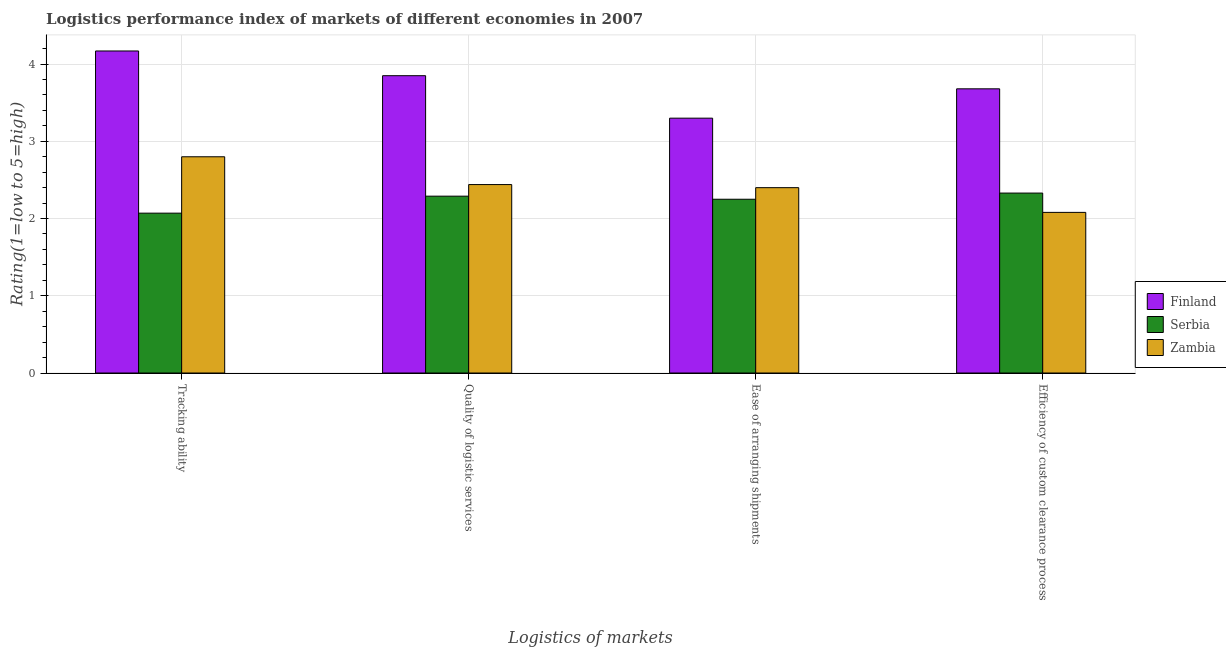Are the number of bars on each tick of the X-axis equal?
Provide a short and direct response. Yes. How many bars are there on the 1st tick from the left?
Provide a succinct answer. 3. What is the label of the 4th group of bars from the left?
Your answer should be compact. Efficiency of custom clearance process. What is the lpi rating of tracking ability in Serbia?
Your answer should be compact. 2.07. Across all countries, what is the maximum lpi rating of efficiency of custom clearance process?
Offer a very short reply. 3.68. Across all countries, what is the minimum lpi rating of tracking ability?
Your answer should be compact. 2.07. In which country was the lpi rating of tracking ability minimum?
Offer a very short reply. Serbia. What is the total lpi rating of tracking ability in the graph?
Provide a short and direct response. 9.04. What is the difference between the lpi rating of ease of arranging shipments in Serbia and that in Zambia?
Your answer should be very brief. -0.15. What is the difference between the lpi rating of ease of arranging shipments in Finland and the lpi rating of tracking ability in Serbia?
Your answer should be compact. 1.23. What is the average lpi rating of efficiency of custom clearance process per country?
Offer a very short reply. 2.7. What is the difference between the lpi rating of quality of logistic services and lpi rating of ease of arranging shipments in Zambia?
Ensure brevity in your answer.  0.04. In how many countries, is the lpi rating of ease of arranging shipments greater than 3.8 ?
Your answer should be very brief. 0. What is the ratio of the lpi rating of tracking ability in Finland to that in Serbia?
Your response must be concise. 2.01. Is the difference between the lpi rating of efficiency of custom clearance process in Zambia and Finland greater than the difference between the lpi rating of ease of arranging shipments in Zambia and Finland?
Offer a very short reply. No. What is the difference between the highest and the second highest lpi rating of tracking ability?
Give a very brief answer. 1.37. What is the difference between the highest and the lowest lpi rating of ease of arranging shipments?
Provide a succinct answer. 1.05. In how many countries, is the lpi rating of ease of arranging shipments greater than the average lpi rating of ease of arranging shipments taken over all countries?
Keep it short and to the point. 1. Is it the case that in every country, the sum of the lpi rating of tracking ability and lpi rating of quality of logistic services is greater than the sum of lpi rating of efficiency of custom clearance process and lpi rating of ease of arranging shipments?
Give a very brief answer. No. What does the 3rd bar from the left in Efficiency of custom clearance process represents?
Your answer should be very brief. Zambia. What does the 3rd bar from the right in Tracking ability represents?
Provide a short and direct response. Finland. Is it the case that in every country, the sum of the lpi rating of tracking ability and lpi rating of quality of logistic services is greater than the lpi rating of ease of arranging shipments?
Make the answer very short. Yes. How many bars are there?
Offer a very short reply. 12. Are all the bars in the graph horizontal?
Provide a succinct answer. No. How many countries are there in the graph?
Offer a terse response. 3. What is the difference between two consecutive major ticks on the Y-axis?
Offer a very short reply. 1. Does the graph contain any zero values?
Give a very brief answer. No. Does the graph contain grids?
Give a very brief answer. Yes. Where does the legend appear in the graph?
Your response must be concise. Center right. How are the legend labels stacked?
Keep it short and to the point. Vertical. What is the title of the graph?
Make the answer very short. Logistics performance index of markets of different economies in 2007. What is the label or title of the X-axis?
Your answer should be compact. Logistics of markets. What is the label or title of the Y-axis?
Offer a terse response. Rating(1=low to 5=high). What is the Rating(1=low to 5=high) of Finland in Tracking ability?
Your response must be concise. 4.17. What is the Rating(1=low to 5=high) in Serbia in Tracking ability?
Give a very brief answer. 2.07. What is the Rating(1=low to 5=high) in Finland in Quality of logistic services?
Provide a succinct answer. 3.85. What is the Rating(1=low to 5=high) in Serbia in Quality of logistic services?
Your answer should be very brief. 2.29. What is the Rating(1=low to 5=high) of Zambia in Quality of logistic services?
Your response must be concise. 2.44. What is the Rating(1=low to 5=high) of Serbia in Ease of arranging shipments?
Your answer should be compact. 2.25. What is the Rating(1=low to 5=high) in Finland in Efficiency of custom clearance process?
Your response must be concise. 3.68. What is the Rating(1=low to 5=high) of Serbia in Efficiency of custom clearance process?
Your answer should be very brief. 2.33. What is the Rating(1=low to 5=high) of Zambia in Efficiency of custom clearance process?
Your answer should be compact. 2.08. Across all Logistics of markets, what is the maximum Rating(1=low to 5=high) in Finland?
Offer a terse response. 4.17. Across all Logistics of markets, what is the maximum Rating(1=low to 5=high) of Serbia?
Give a very brief answer. 2.33. Across all Logistics of markets, what is the maximum Rating(1=low to 5=high) in Zambia?
Your response must be concise. 2.8. Across all Logistics of markets, what is the minimum Rating(1=low to 5=high) in Finland?
Make the answer very short. 3.3. Across all Logistics of markets, what is the minimum Rating(1=low to 5=high) in Serbia?
Offer a terse response. 2.07. Across all Logistics of markets, what is the minimum Rating(1=low to 5=high) in Zambia?
Provide a short and direct response. 2.08. What is the total Rating(1=low to 5=high) of Finland in the graph?
Your answer should be very brief. 15. What is the total Rating(1=low to 5=high) of Serbia in the graph?
Keep it short and to the point. 8.94. What is the total Rating(1=low to 5=high) in Zambia in the graph?
Your response must be concise. 9.72. What is the difference between the Rating(1=low to 5=high) of Finland in Tracking ability and that in Quality of logistic services?
Offer a terse response. 0.32. What is the difference between the Rating(1=low to 5=high) in Serbia in Tracking ability and that in Quality of logistic services?
Your answer should be compact. -0.22. What is the difference between the Rating(1=low to 5=high) of Zambia in Tracking ability and that in Quality of logistic services?
Your response must be concise. 0.36. What is the difference between the Rating(1=low to 5=high) in Finland in Tracking ability and that in Ease of arranging shipments?
Your answer should be very brief. 0.87. What is the difference between the Rating(1=low to 5=high) of Serbia in Tracking ability and that in Ease of arranging shipments?
Give a very brief answer. -0.18. What is the difference between the Rating(1=low to 5=high) in Finland in Tracking ability and that in Efficiency of custom clearance process?
Provide a succinct answer. 0.49. What is the difference between the Rating(1=low to 5=high) of Serbia in Tracking ability and that in Efficiency of custom clearance process?
Provide a succinct answer. -0.26. What is the difference between the Rating(1=low to 5=high) of Zambia in Tracking ability and that in Efficiency of custom clearance process?
Your answer should be very brief. 0.72. What is the difference between the Rating(1=low to 5=high) in Finland in Quality of logistic services and that in Ease of arranging shipments?
Keep it short and to the point. 0.55. What is the difference between the Rating(1=low to 5=high) of Zambia in Quality of logistic services and that in Ease of arranging shipments?
Your answer should be compact. 0.04. What is the difference between the Rating(1=low to 5=high) in Finland in Quality of logistic services and that in Efficiency of custom clearance process?
Your answer should be very brief. 0.17. What is the difference between the Rating(1=low to 5=high) in Serbia in Quality of logistic services and that in Efficiency of custom clearance process?
Your response must be concise. -0.04. What is the difference between the Rating(1=low to 5=high) in Zambia in Quality of logistic services and that in Efficiency of custom clearance process?
Provide a short and direct response. 0.36. What is the difference between the Rating(1=low to 5=high) of Finland in Ease of arranging shipments and that in Efficiency of custom clearance process?
Your answer should be very brief. -0.38. What is the difference between the Rating(1=low to 5=high) in Serbia in Ease of arranging shipments and that in Efficiency of custom clearance process?
Your response must be concise. -0.08. What is the difference between the Rating(1=low to 5=high) in Zambia in Ease of arranging shipments and that in Efficiency of custom clearance process?
Ensure brevity in your answer.  0.32. What is the difference between the Rating(1=low to 5=high) of Finland in Tracking ability and the Rating(1=low to 5=high) of Serbia in Quality of logistic services?
Give a very brief answer. 1.88. What is the difference between the Rating(1=low to 5=high) of Finland in Tracking ability and the Rating(1=low to 5=high) of Zambia in Quality of logistic services?
Your response must be concise. 1.73. What is the difference between the Rating(1=low to 5=high) of Serbia in Tracking ability and the Rating(1=low to 5=high) of Zambia in Quality of logistic services?
Keep it short and to the point. -0.37. What is the difference between the Rating(1=low to 5=high) in Finland in Tracking ability and the Rating(1=low to 5=high) in Serbia in Ease of arranging shipments?
Keep it short and to the point. 1.92. What is the difference between the Rating(1=low to 5=high) in Finland in Tracking ability and the Rating(1=low to 5=high) in Zambia in Ease of arranging shipments?
Offer a terse response. 1.77. What is the difference between the Rating(1=low to 5=high) in Serbia in Tracking ability and the Rating(1=low to 5=high) in Zambia in Ease of arranging shipments?
Make the answer very short. -0.33. What is the difference between the Rating(1=low to 5=high) of Finland in Tracking ability and the Rating(1=low to 5=high) of Serbia in Efficiency of custom clearance process?
Make the answer very short. 1.84. What is the difference between the Rating(1=low to 5=high) in Finland in Tracking ability and the Rating(1=low to 5=high) in Zambia in Efficiency of custom clearance process?
Your answer should be very brief. 2.09. What is the difference between the Rating(1=low to 5=high) of Serbia in Tracking ability and the Rating(1=low to 5=high) of Zambia in Efficiency of custom clearance process?
Make the answer very short. -0.01. What is the difference between the Rating(1=low to 5=high) in Finland in Quality of logistic services and the Rating(1=low to 5=high) in Serbia in Ease of arranging shipments?
Offer a very short reply. 1.6. What is the difference between the Rating(1=low to 5=high) of Finland in Quality of logistic services and the Rating(1=low to 5=high) of Zambia in Ease of arranging shipments?
Keep it short and to the point. 1.45. What is the difference between the Rating(1=low to 5=high) in Serbia in Quality of logistic services and the Rating(1=low to 5=high) in Zambia in Ease of arranging shipments?
Provide a succinct answer. -0.11. What is the difference between the Rating(1=low to 5=high) in Finland in Quality of logistic services and the Rating(1=low to 5=high) in Serbia in Efficiency of custom clearance process?
Ensure brevity in your answer.  1.52. What is the difference between the Rating(1=low to 5=high) of Finland in Quality of logistic services and the Rating(1=low to 5=high) of Zambia in Efficiency of custom clearance process?
Offer a very short reply. 1.77. What is the difference between the Rating(1=low to 5=high) of Serbia in Quality of logistic services and the Rating(1=low to 5=high) of Zambia in Efficiency of custom clearance process?
Provide a succinct answer. 0.21. What is the difference between the Rating(1=low to 5=high) of Finland in Ease of arranging shipments and the Rating(1=low to 5=high) of Serbia in Efficiency of custom clearance process?
Keep it short and to the point. 0.97. What is the difference between the Rating(1=low to 5=high) of Finland in Ease of arranging shipments and the Rating(1=low to 5=high) of Zambia in Efficiency of custom clearance process?
Ensure brevity in your answer.  1.22. What is the difference between the Rating(1=low to 5=high) in Serbia in Ease of arranging shipments and the Rating(1=low to 5=high) in Zambia in Efficiency of custom clearance process?
Make the answer very short. 0.17. What is the average Rating(1=low to 5=high) of Finland per Logistics of markets?
Offer a very short reply. 3.75. What is the average Rating(1=low to 5=high) of Serbia per Logistics of markets?
Ensure brevity in your answer.  2.23. What is the average Rating(1=low to 5=high) of Zambia per Logistics of markets?
Make the answer very short. 2.43. What is the difference between the Rating(1=low to 5=high) in Finland and Rating(1=low to 5=high) in Zambia in Tracking ability?
Provide a succinct answer. 1.37. What is the difference between the Rating(1=low to 5=high) of Serbia and Rating(1=low to 5=high) of Zambia in Tracking ability?
Your answer should be compact. -0.73. What is the difference between the Rating(1=low to 5=high) in Finland and Rating(1=low to 5=high) in Serbia in Quality of logistic services?
Provide a succinct answer. 1.56. What is the difference between the Rating(1=low to 5=high) of Finland and Rating(1=low to 5=high) of Zambia in Quality of logistic services?
Keep it short and to the point. 1.41. What is the difference between the Rating(1=low to 5=high) in Serbia and Rating(1=low to 5=high) in Zambia in Quality of logistic services?
Make the answer very short. -0.15. What is the difference between the Rating(1=low to 5=high) in Finland and Rating(1=low to 5=high) in Serbia in Ease of arranging shipments?
Your answer should be very brief. 1.05. What is the difference between the Rating(1=low to 5=high) in Finland and Rating(1=low to 5=high) in Zambia in Ease of arranging shipments?
Your answer should be very brief. 0.9. What is the difference between the Rating(1=low to 5=high) of Finland and Rating(1=low to 5=high) of Serbia in Efficiency of custom clearance process?
Make the answer very short. 1.35. What is the difference between the Rating(1=low to 5=high) of Finland and Rating(1=low to 5=high) of Zambia in Efficiency of custom clearance process?
Ensure brevity in your answer.  1.6. What is the ratio of the Rating(1=low to 5=high) of Finland in Tracking ability to that in Quality of logistic services?
Make the answer very short. 1.08. What is the ratio of the Rating(1=low to 5=high) of Serbia in Tracking ability to that in Quality of logistic services?
Make the answer very short. 0.9. What is the ratio of the Rating(1=low to 5=high) in Zambia in Tracking ability to that in Quality of logistic services?
Keep it short and to the point. 1.15. What is the ratio of the Rating(1=low to 5=high) of Finland in Tracking ability to that in Ease of arranging shipments?
Your response must be concise. 1.26. What is the ratio of the Rating(1=low to 5=high) in Zambia in Tracking ability to that in Ease of arranging shipments?
Ensure brevity in your answer.  1.17. What is the ratio of the Rating(1=low to 5=high) in Finland in Tracking ability to that in Efficiency of custom clearance process?
Offer a very short reply. 1.13. What is the ratio of the Rating(1=low to 5=high) of Serbia in Tracking ability to that in Efficiency of custom clearance process?
Ensure brevity in your answer.  0.89. What is the ratio of the Rating(1=low to 5=high) of Zambia in Tracking ability to that in Efficiency of custom clearance process?
Give a very brief answer. 1.35. What is the ratio of the Rating(1=low to 5=high) of Finland in Quality of logistic services to that in Ease of arranging shipments?
Your answer should be compact. 1.17. What is the ratio of the Rating(1=low to 5=high) in Serbia in Quality of logistic services to that in Ease of arranging shipments?
Keep it short and to the point. 1.02. What is the ratio of the Rating(1=low to 5=high) in Zambia in Quality of logistic services to that in Ease of arranging shipments?
Provide a short and direct response. 1.02. What is the ratio of the Rating(1=low to 5=high) of Finland in Quality of logistic services to that in Efficiency of custom clearance process?
Offer a very short reply. 1.05. What is the ratio of the Rating(1=low to 5=high) of Serbia in Quality of logistic services to that in Efficiency of custom clearance process?
Keep it short and to the point. 0.98. What is the ratio of the Rating(1=low to 5=high) in Zambia in Quality of logistic services to that in Efficiency of custom clearance process?
Keep it short and to the point. 1.17. What is the ratio of the Rating(1=low to 5=high) in Finland in Ease of arranging shipments to that in Efficiency of custom clearance process?
Give a very brief answer. 0.9. What is the ratio of the Rating(1=low to 5=high) in Serbia in Ease of arranging shipments to that in Efficiency of custom clearance process?
Your answer should be very brief. 0.97. What is the ratio of the Rating(1=low to 5=high) of Zambia in Ease of arranging shipments to that in Efficiency of custom clearance process?
Provide a short and direct response. 1.15. What is the difference between the highest and the second highest Rating(1=low to 5=high) in Finland?
Keep it short and to the point. 0.32. What is the difference between the highest and the second highest Rating(1=low to 5=high) of Serbia?
Provide a succinct answer. 0.04. What is the difference between the highest and the second highest Rating(1=low to 5=high) in Zambia?
Offer a very short reply. 0.36. What is the difference between the highest and the lowest Rating(1=low to 5=high) of Finland?
Your answer should be very brief. 0.87. What is the difference between the highest and the lowest Rating(1=low to 5=high) of Serbia?
Your answer should be compact. 0.26. What is the difference between the highest and the lowest Rating(1=low to 5=high) in Zambia?
Offer a terse response. 0.72. 